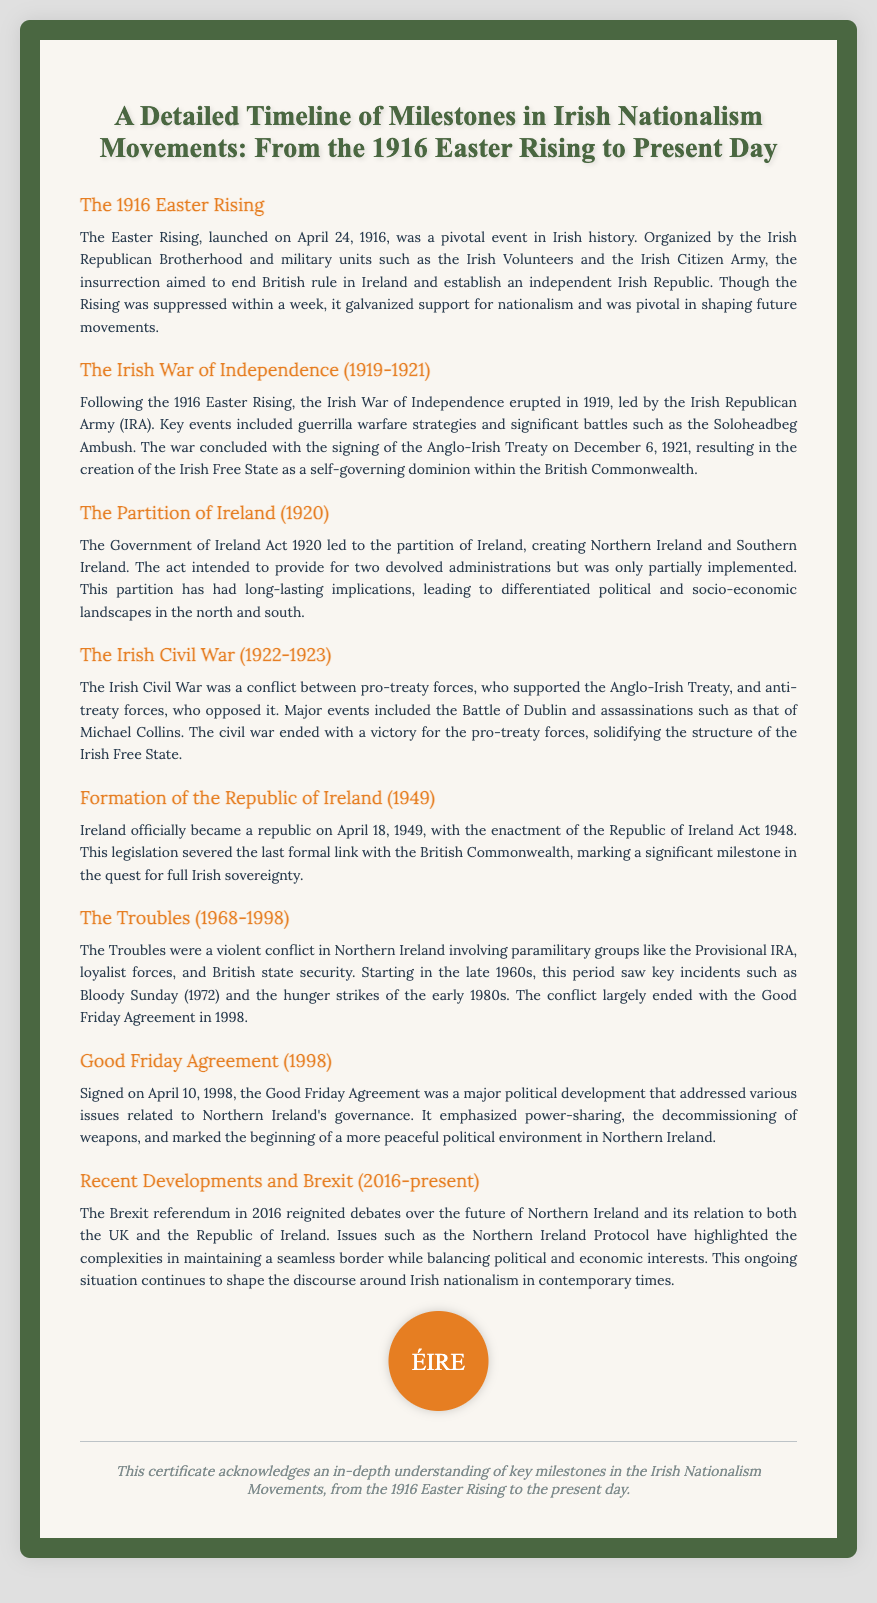What was the date of the Easter Rising? The document states that the Easter Rising was launched on April 24, 1916.
Answer: April 24, 1916 What treaty ended the Irish War of Independence? The end of the Irish War of Independence was marked by the signing of the Anglo-Irish Treaty on December 6, 1921.
Answer: Anglo-Irish Treaty What significant event in Northern Ireland is referred to as "Bloody Sunday"? The Troubles section highlights that Bloody Sunday occurred in 1972, marking a key incident in the conflict.
Answer: 1972 What was the outcome of the Irish Civil War? The document notes that the civil war ended with a victory for the pro-treaty forces, solidifying the Irish Free State's structure.
Answer: Victory for pro-treaty forces When did Ireland officially become a republic? The document indicates that Ireland became a republic on April 18, 1949, through the enactment of the Republic of Ireland Act 1948.
Answer: April 18, 1949 What document addressed governance issues in Northern Ireland in 1998? The Good Friday Agreement signed on April 10, 1998, is mentioned as a major political development addressing governance in Northern Ireland.
Answer: Good Friday Agreement What ongoing situation has influenced Irish nationalism since 2016? The document references the Brexit referendum in 2016 as a significant event impacting discussions around Irish nationalism.
Answer: Brexit How long did the Troubles last? The document specifies that the Troubles lasted from 1968 to 1998.
Answer: 30 years 